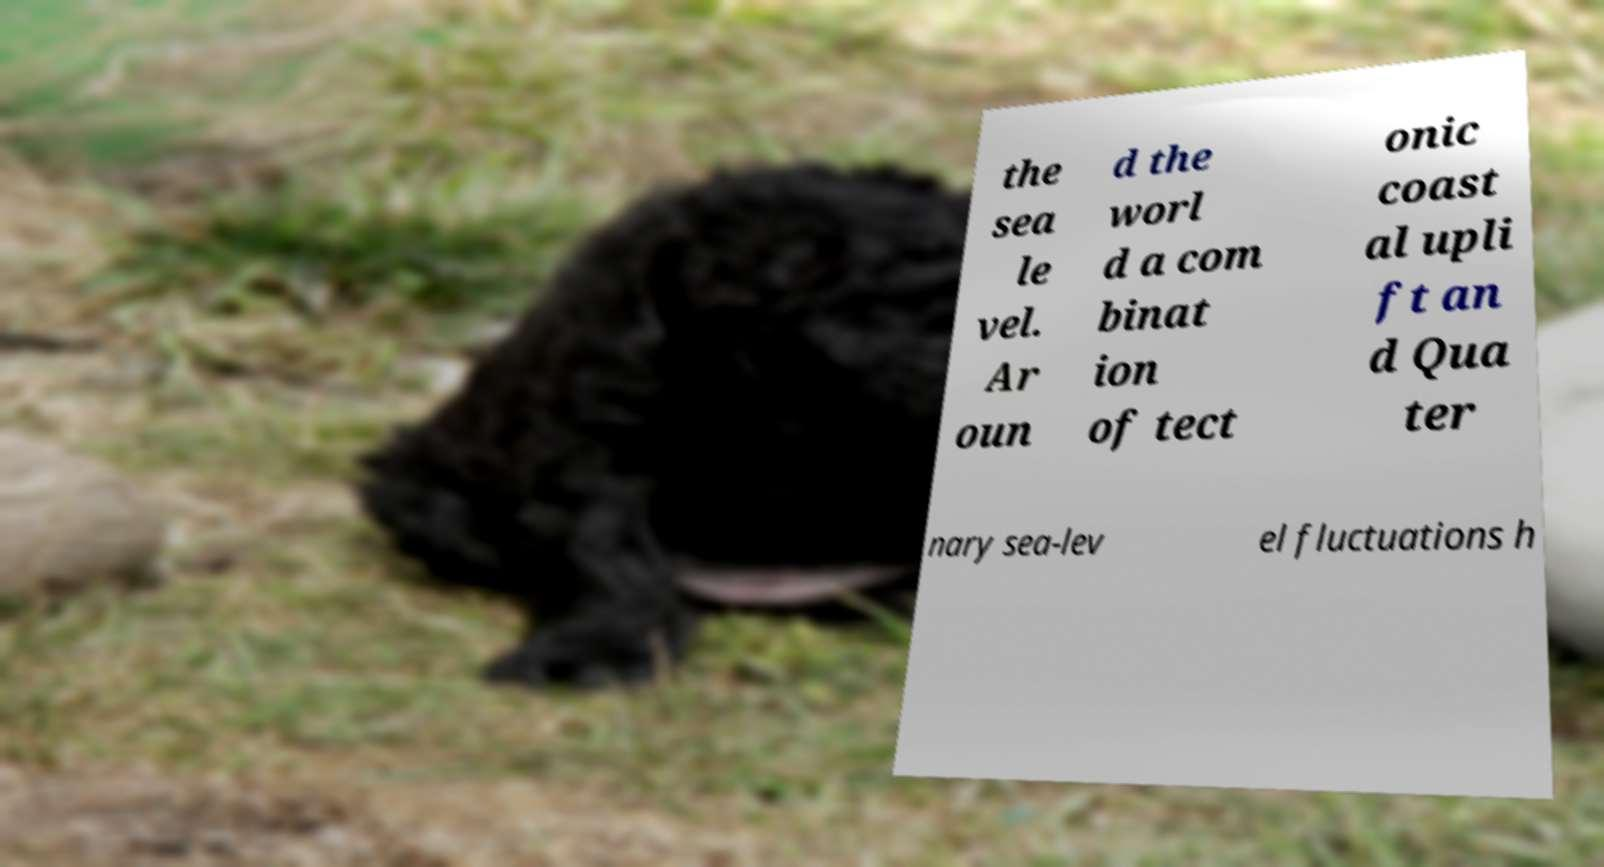Please read and relay the text visible in this image. What does it say? the sea le vel. Ar oun d the worl d a com binat ion of tect onic coast al upli ft an d Qua ter nary sea-lev el fluctuations h 